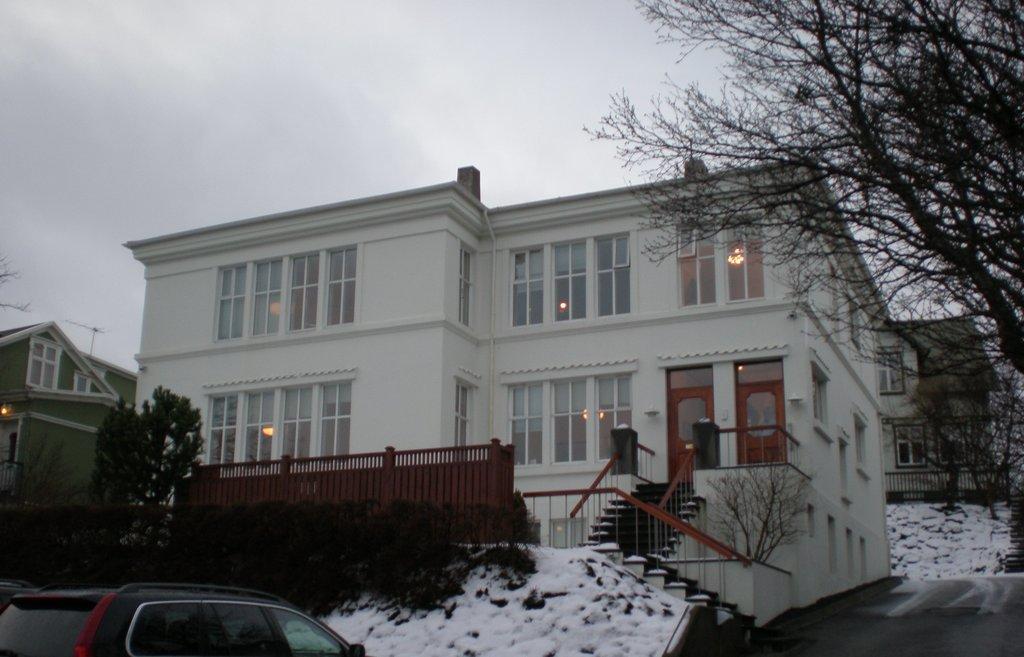How would you summarize this image in a sentence or two? In this image I can see three buildings. I can see few trees. I can see the staircase. I can see a car. At the top I can see clouds in the sky. 